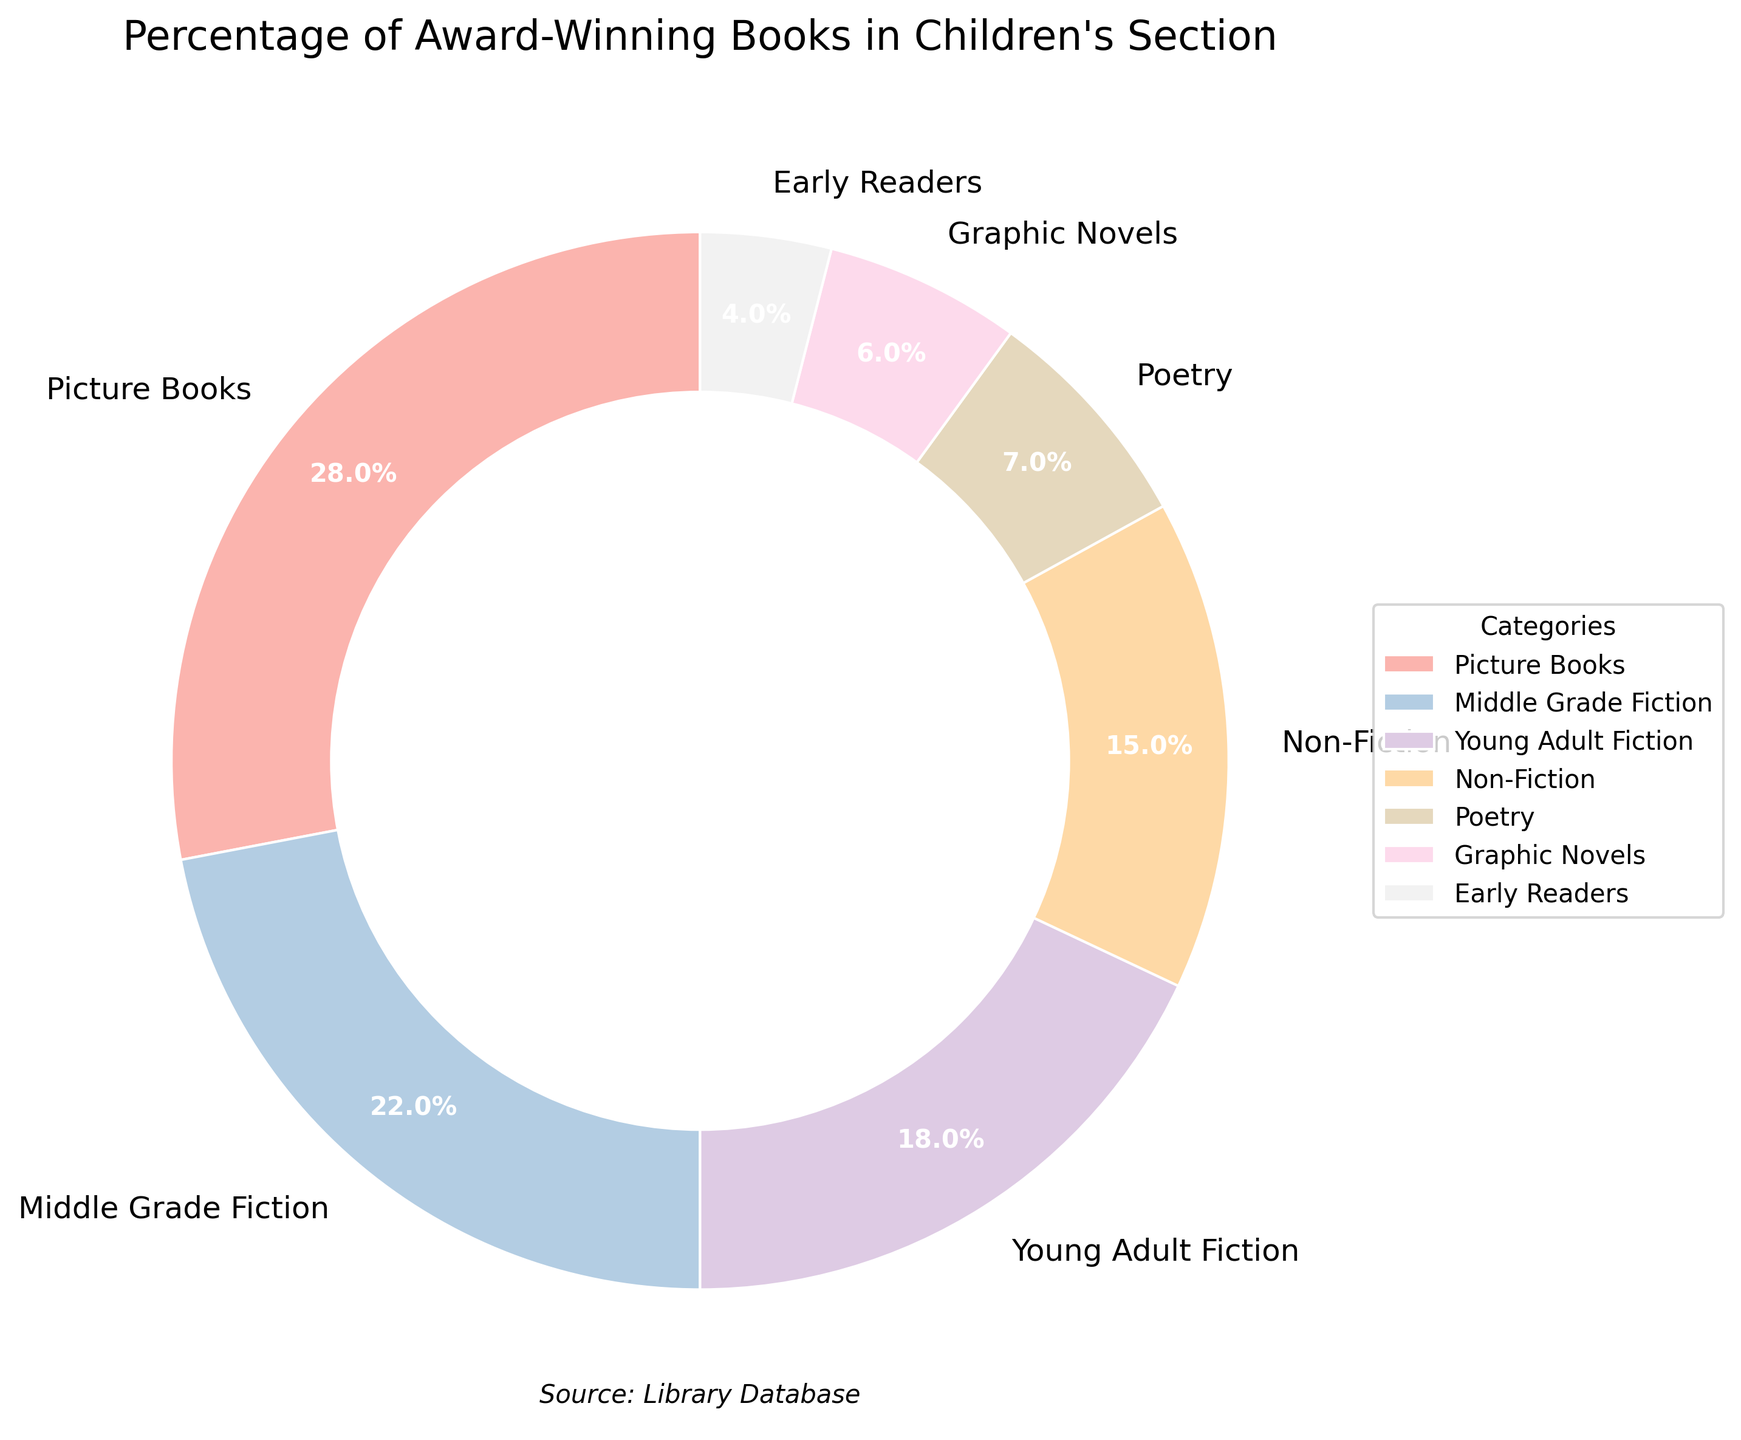Which category has the highest percentage of award-winning books? The chart shows that Picture Books have the largest slice of the pie chart, labeled with 28%.
Answer: Picture Books Which category has the smallest percentage of award-winning books? The chart shows that Early Readers have the smallest slice of the pie chart, labeled with 4%.
Answer: Early Readers What is the combined percentage of award-winning books in the Middle Grade Fiction and Young Adult Fiction categories? Add the percentages for Middle Grade Fiction (22%) and Young Adult Fiction (18%): 22% + 18% = 40%.
Answer: 40% How much greater is the percentage of award-winning Picture Books compared to Non-Fiction books? Subtract the percentage for Non-Fiction (15%) from the percentage for Picture Books (28%): 28% - 15% = 13%.
Answer: 13% What percentage of award-winning books is in categories other than Picture Books and Middle Grade Fiction? Subtract the combined percentage of Picture Books (28%) and Middle Grade Fiction (22%) from 100%: 100% - (28% + 22%) = 50%.
Answer: 50% Which two categories combined make up more than half of the award-winning books in the children's section? Picture Books (28%) and Middle Grade Fiction (22%) together make 50%, which is exactly half. To exceed half, we consider Picture Books (28%) + Young Adult Fiction (18%) = 46% and compare with other category combinations. Only Picture Books (28%) + another 22% or higher category will exceed. Middle Grade Fiction (22%) + Young Adult Fiction (18%) is too low. Thus, Picture Books and Middle Grade Fiction fits together.
Answer: Picture Books and Middle Grade Fiction What is the difference in the percentage of award-winning books between Poetry and Non-Fiction categories? Subtract the percentage for Poetry (7%) from the percentage for Non-Fiction (15%): 15% - 7% = 8%.
Answer: 8% Which category, excluding Picture Books, has the second highest percentage of award-winning books? Excluding Picture Books (28%), the next highest percentage visible from the chart is Middle Grade Fiction at 22%.
Answer: Middle Grade Fiction 